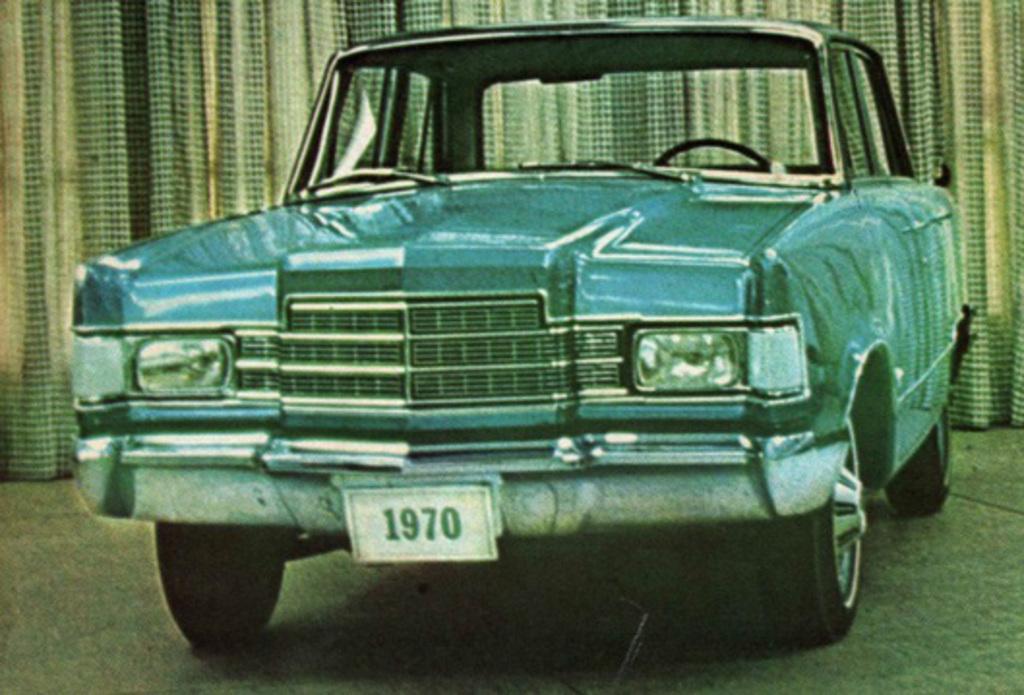How would you summarize this image in a sentence or two? In this image there is a car on a surface, in the background there is a curtain. 